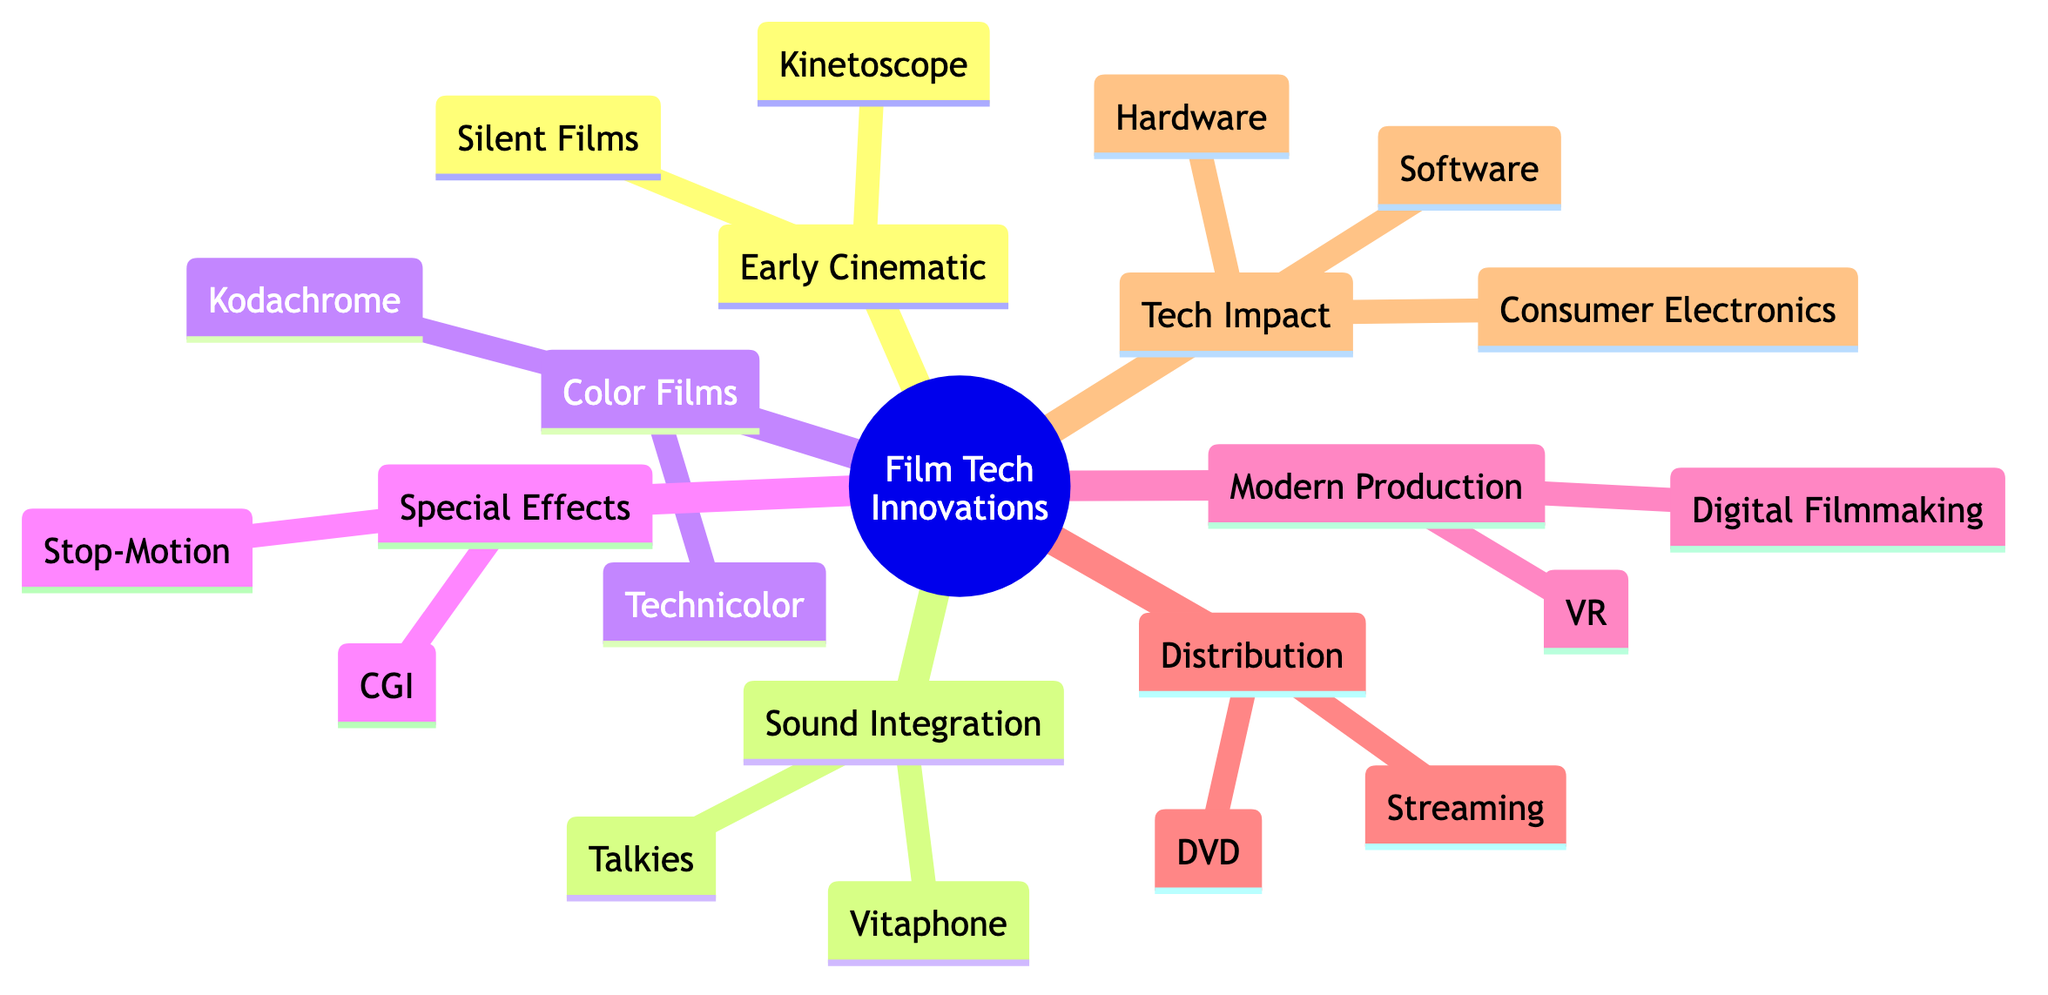What are the two main categories of early cinematic techniques? The mind map indicates that "Early Cinematic Techniques" splits into two subcategories: "Silent Films" and "Kinetoscope".
Answer: Silent Films, Kinetoscope How many innovations are listed under "Color Films"? The "Color Films" branch contains two innovations: "Technicolor" and "Kodachrome". Therefore, there are two innovations listed.
Answer: 2 What major innovation in sound integration began in 1927? The mind map identifies "Talkies" as the major innovation that started to incorporate sound in films beginning in 1927.
Answer: Talkies Which special effect technique was pioneered by the film "King Kong"? "Stop-Motion Animation" is highlighted in the diagram and specifically noted as being pioneered by the film "King Kong" (1933).
Answer: Stop-Motion Animation Under "Impact on Tech Development", what does the section on software development refer to? It discusses the development of software used for film editing, specifically naming programs like "Adobe Premiere" and "Final Cut Pro", indicating their significance in the film industry.
Answer: Software Development What is the relationship between "Streaming Services" and "Distribution Methods"? "Streaming Services" is a sub-branch under "Distribution Methods", showing that it is one of the modern ways films are distributed.
Answer: Sub-branch How did digital filmmaking impact the transition in production techniques? The diagram illustrates that "Digital Filmmaking" represents a significant shift from traditional film to digital technologies in film production, which is a key point under "Modern Production Techniques".
Answer: Shift Which technology was replaced by DVDs in the late 1990s? The mind map states that DVDs replaced "VHS tapes", which indicates a significant change in media storage and consumption formats.
Answer: VHS tapes What major film used Technicolor? The mind map lists "The Wizard of Oz" as a notable film that utilized the Technicolor system, emphasizing the film's contribution to color cinema.
Answer: The Wizard of Oz 